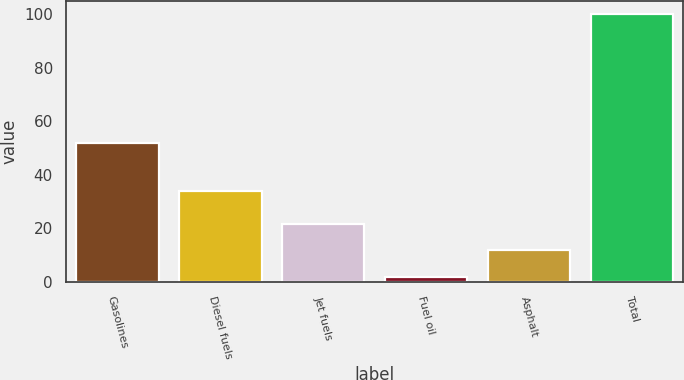Convert chart to OTSL. <chart><loc_0><loc_0><loc_500><loc_500><bar_chart><fcel>Gasolines<fcel>Diesel fuels<fcel>Jet fuels<fcel>Fuel oil<fcel>Asphalt<fcel>Total<nl><fcel>52<fcel>34<fcel>21.6<fcel>2<fcel>11.8<fcel>100<nl></chart> 